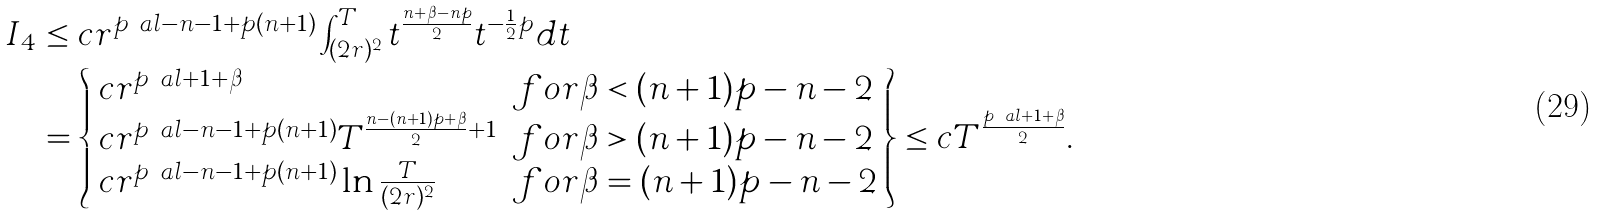Convert formula to latex. <formula><loc_0><loc_0><loc_500><loc_500>I _ { 4 } & \leq c r ^ { p \ a l - n - 1 + p ( n + 1 ) } \int _ { ( 2 r ) ^ { 2 } } ^ { T } t ^ { \frac { n + \beta - n p } { 2 } } t ^ { - \frac { 1 } { 2 } p } d t \\ & = \left \{ \begin{array} { l l } c r ^ { p \ a l + 1 + \beta } & f o r \beta < ( n + 1 ) p - n - 2 \\ c r ^ { p \ a l - n - 1 + p ( n + 1 ) } T ^ { \frac { n - ( n + 1 ) p + \beta } { 2 } + 1 } & f o r \beta > ( n + 1 ) p - n - 2 \\ c r ^ { p \ a l - n - 1 + p ( n + 1 ) } \ln \frac { T } { ( 2 r ) ^ { 2 } } & f o r \beta = ( n + 1 ) p - n - 2 \end{array} \right \} \leq c T ^ { \frac { p \ a l + 1 + \beta } { 2 } } .</formula> 